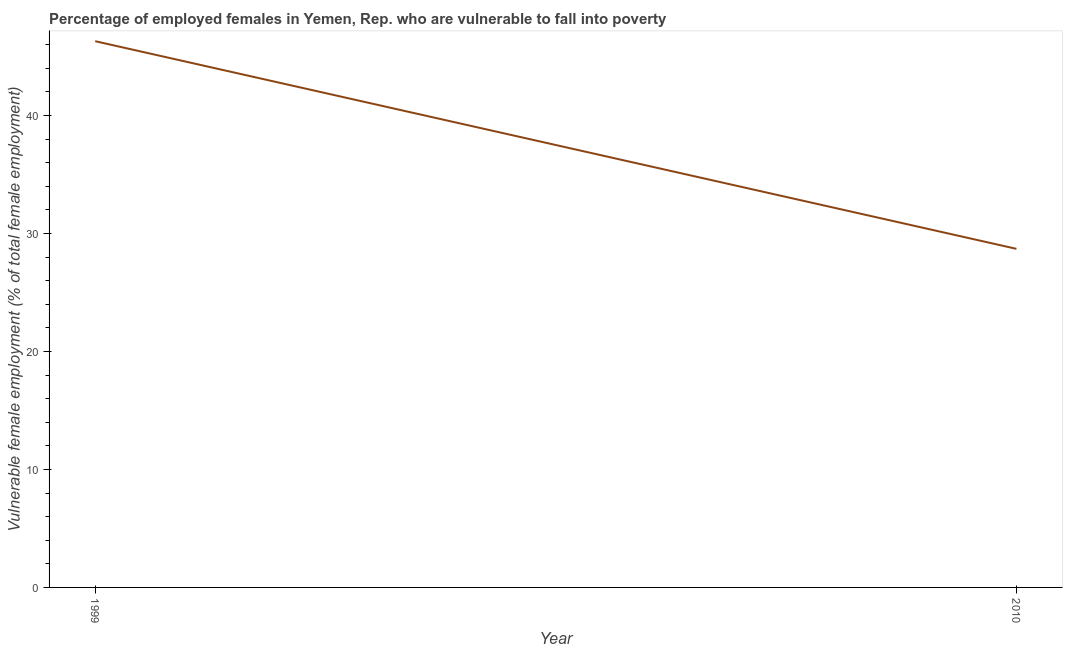What is the percentage of employed females who are vulnerable to fall into poverty in 2010?
Offer a very short reply. 28.7. Across all years, what is the maximum percentage of employed females who are vulnerable to fall into poverty?
Make the answer very short. 46.3. Across all years, what is the minimum percentage of employed females who are vulnerable to fall into poverty?
Your response must be concise. 28.7. In which year was the percentage of employed females who are vulnerable to fall into poverty maximum?
Your response must be concise. 1999. What is the difference between the percentage of employed females who are vulnerable to fall into poverty in 1999 and 2010?
Provide a short and direct response. 17.6. What is the average percentage of employed females who are vulnerable to fall into poverty per year?
Keep it short and to the point. 37.5. What is the median percentage of employed females who are vulnerable to fall into poverty?
Keep it short and to the point. 37.5. In how many years, is the percentage of employed females who are vulnerable to fall into poverty greater than 16 %?
Provide a short and direct response. 2. What is the ratio of the percentage of employed females who are vulnerable to fall into poverty in 1999 to that in 2010?
Offer a very short reply. 1.61. Is the percentage of employed females who are vulnerable to fall into poverty in 1999 less than that in 2010?
Offer a very short reply. No. In how many years, is the percentage of employed females who are vulnerable to fall into poverty greater than the average percentage of employed females who are vulnerable to fall into poverty taken over all years?
Ensure brevity in your answer.  1. How many lines are there?
Your response must be concise. 1. How many years are there in the graph?
Give a very brief answer. 2. What is the difference between two consecutive major ticks on the Y-axis?
Ensure brevity in your answer.  10. Are the values on the major ticks of Y-axis written in scientific E-notation?
Your answer should be very brief. No. Does the graph contain grids?
Keep it short and to the point. No. What is the title of the graph?
Provide a succinct answer. Percentage of employed females in Yemen, Rep. who are vulnerable to fall into poverty. What is the label or title of the Y-axis?
Offer a very short reply. Vulnerable female employment (% of total female employment). What is the Vulnerable female employment (% of total female employment) of 1999?
Offer a terse response. 46.3. What is the Vulnerable female employment (% of total female employment) of 2010?
Your response must be concise. 28.7. What is the ratio of the Vulnerable female employment (% of total female employment) in 1999 to that in 2010?
Your answer should be compact. 1.61. 